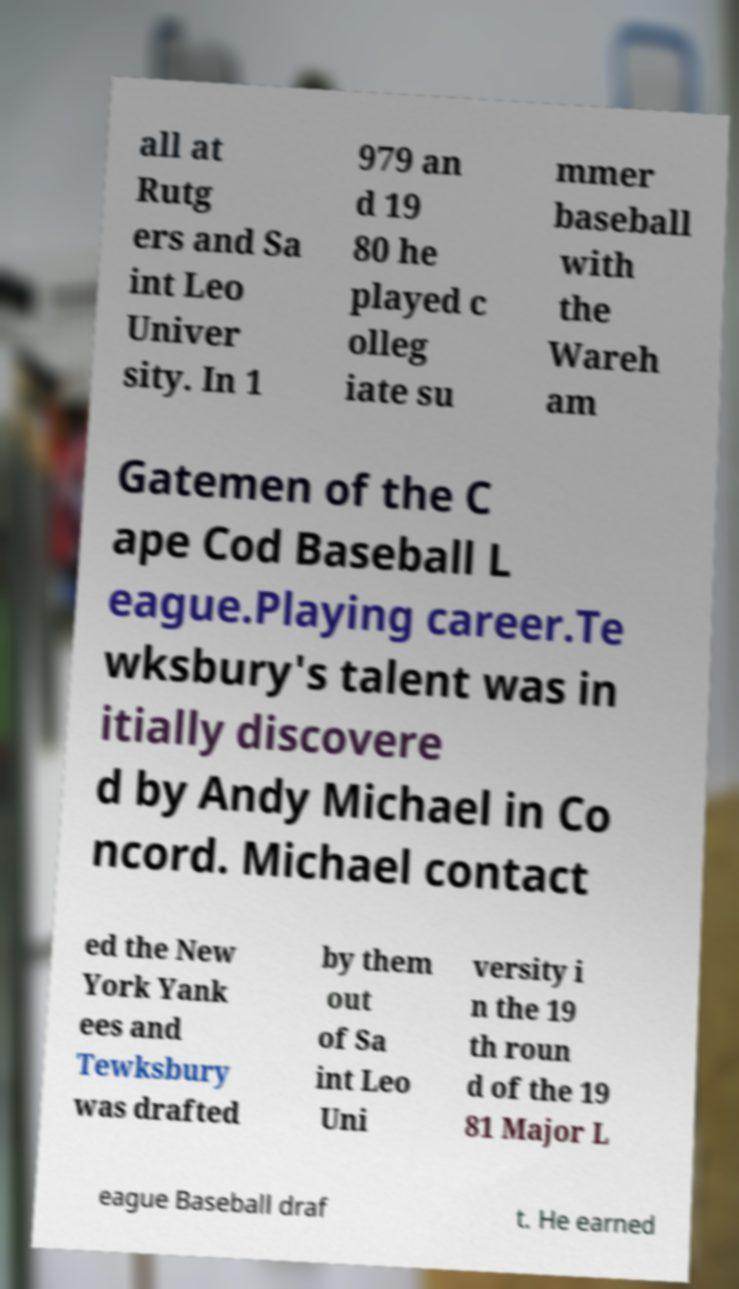I need the written content from this picture converted into text. Can you do that? all at Rutg ers and Sa int Leo Univer sity. In 1 979 an d 19 80 he played c olleg iate su mmer baseball with the Wareh am Gatemen of the C ape Cod Baseball L eague.Playing career.Te wksbury's talent was in itially discovere d by Andy Michael in Co ncord. Michael contact ed the New York Yank ees and Tewksbury was drafted by them out of Sa int Leo Uni versity i n the 19 th roun d of the 19 81 Major L eague Baseball draf t. He earned 